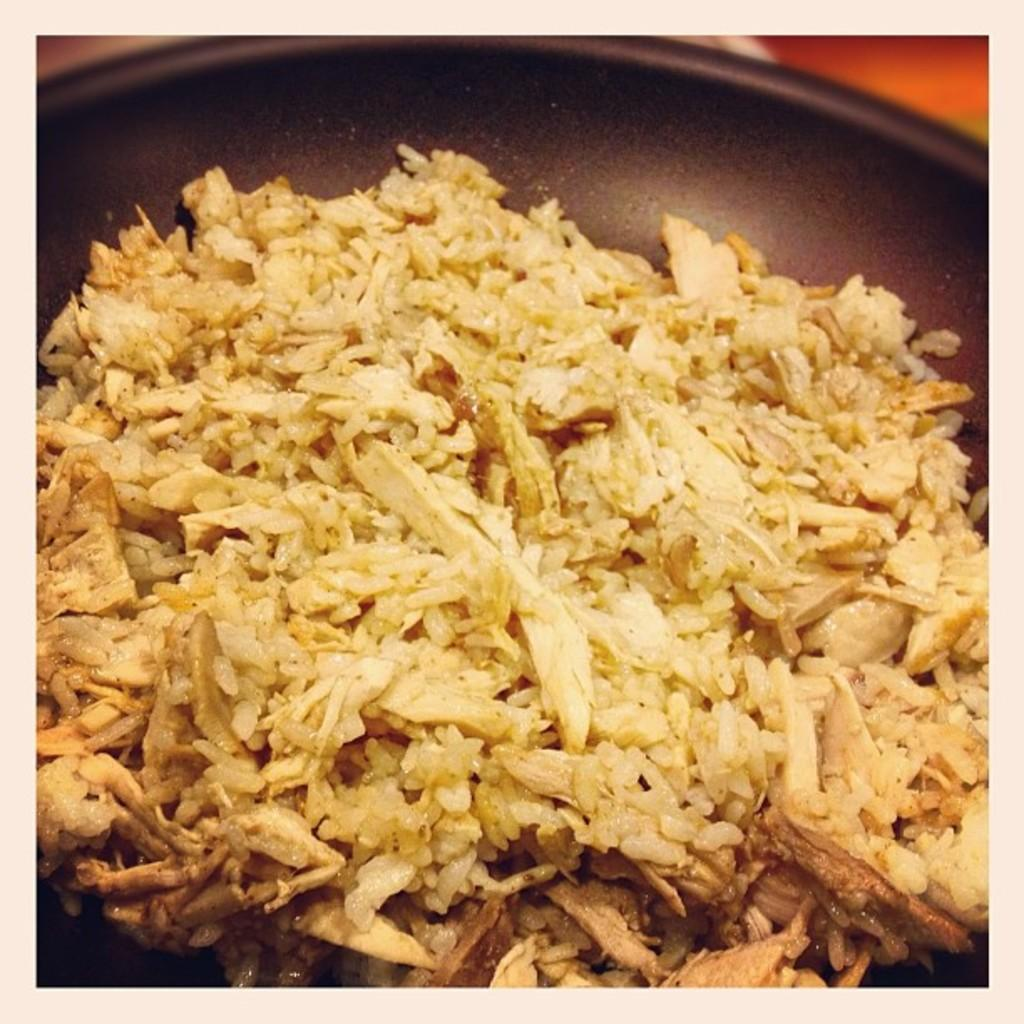What is the main subject of the image? There is a food item in the image. How is the food item presented in the image? The food item is in a bowl. What type of vest is being worn by the flame in the image? There is no flame or vest present in the image. 